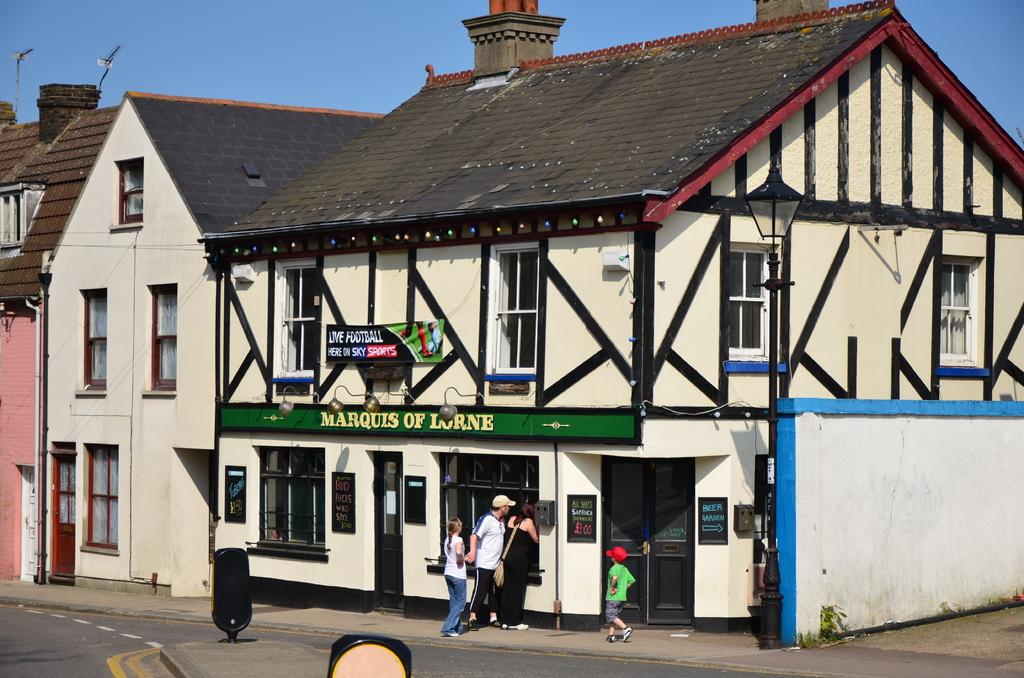How many people are in the foreground of the image? There are four persons in the foreground of the image. Where are the persons located? The persons are on the road. What can be seen in the foreground of the image besides the people? There are boards in the foreground of the image. What type of structures are visible in the image? There are buildings in the image. What architectural feature can be seen in the buildings? There are windows in the image. What is visible in the background of the image? The sky is visible in the background of the image. What might be the time of day when the image was taken? The image might have been taken during the day, as the sky is visible. What type of patch is being used for learning in the image? There is no patch or learning activity visible in the image. 